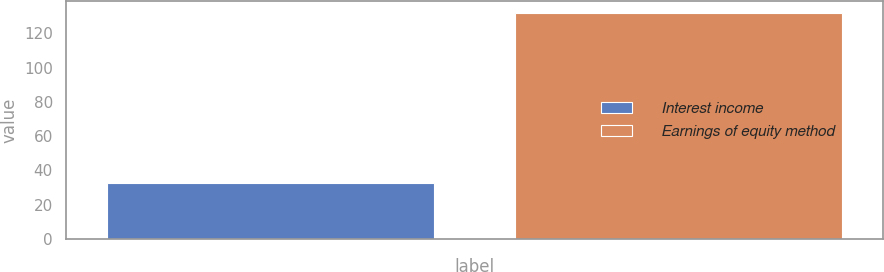<chart> <loc_0><loc_0><loc_500><loc_500><bar_chart><fcel>Interest income<fcel>Earnings of equity method<nl><fcel>33<fcel>132<nl></chart> 